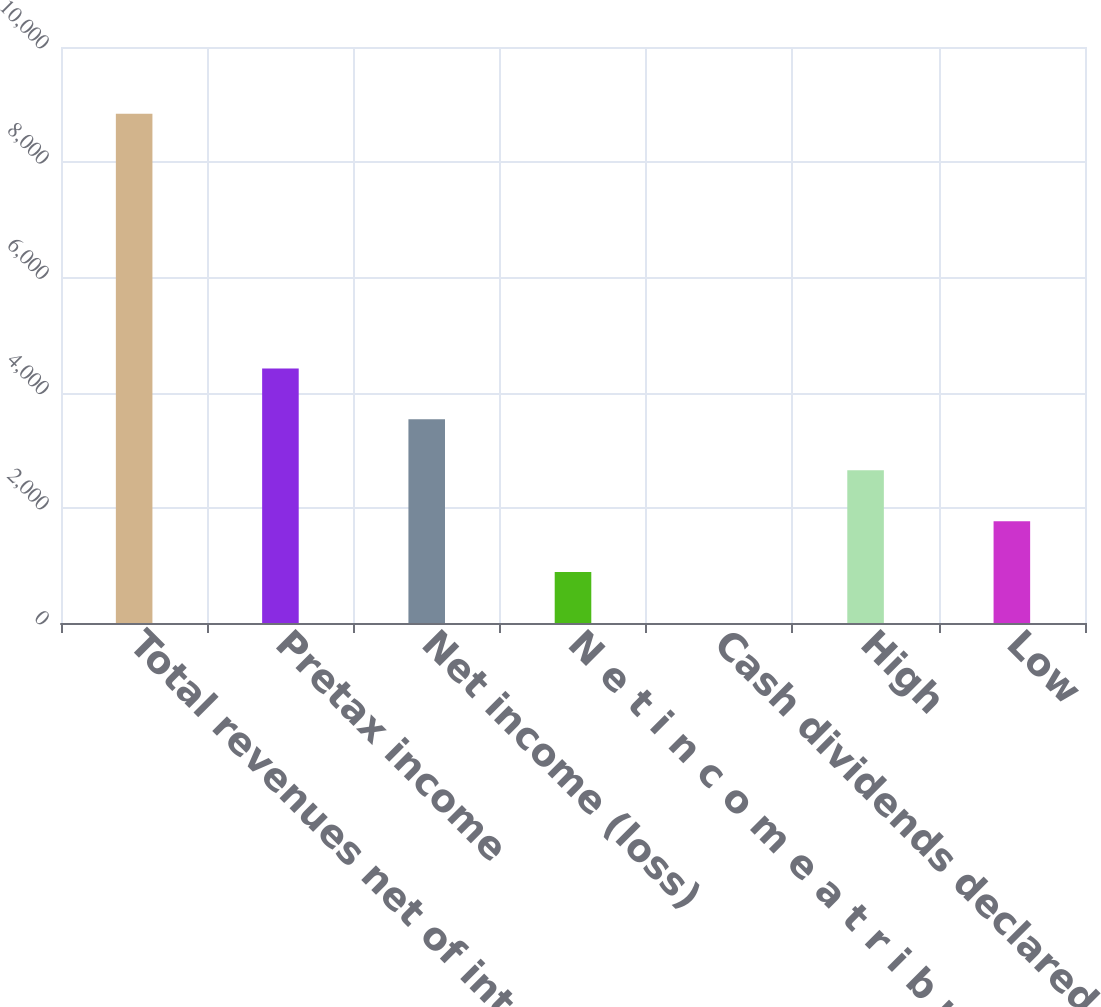Convert chart to OTSL. <chart><loc_0><loc_0><loc_500><loc_500><bar_chart><fcel>Total revenues net of interest<fcel>Pretax income<fcel>Net income (loss)<fcel>N e t i n c o m e a t r i b u<fcel>Cash dividends declared per<fcel>High<fcel>Low<nl><fcel>8839<fcel>4419.68<fcel>3535.81<fcel>884.22<fcel>0.35<fcel>2651.95<fcel>1768.09<nl></chart> 